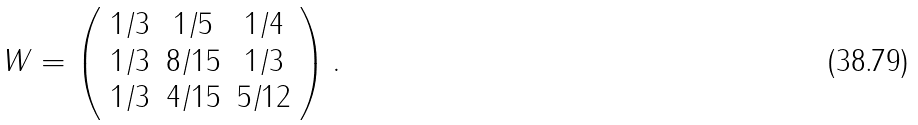Convert formula to latex. <formula><loc_0><loc_0><loc_500><loc_500>W = \left ( \begin{array} { c c c } 1 / 3 & 1 / 5 & 1 / 4 \\ 1 / 3 & 8 / 1 5 & 1 / 3 \\ 1 / 3 & 4 / 1 5 & 5 / 1 2 \end{array} \right ) .</formula> 